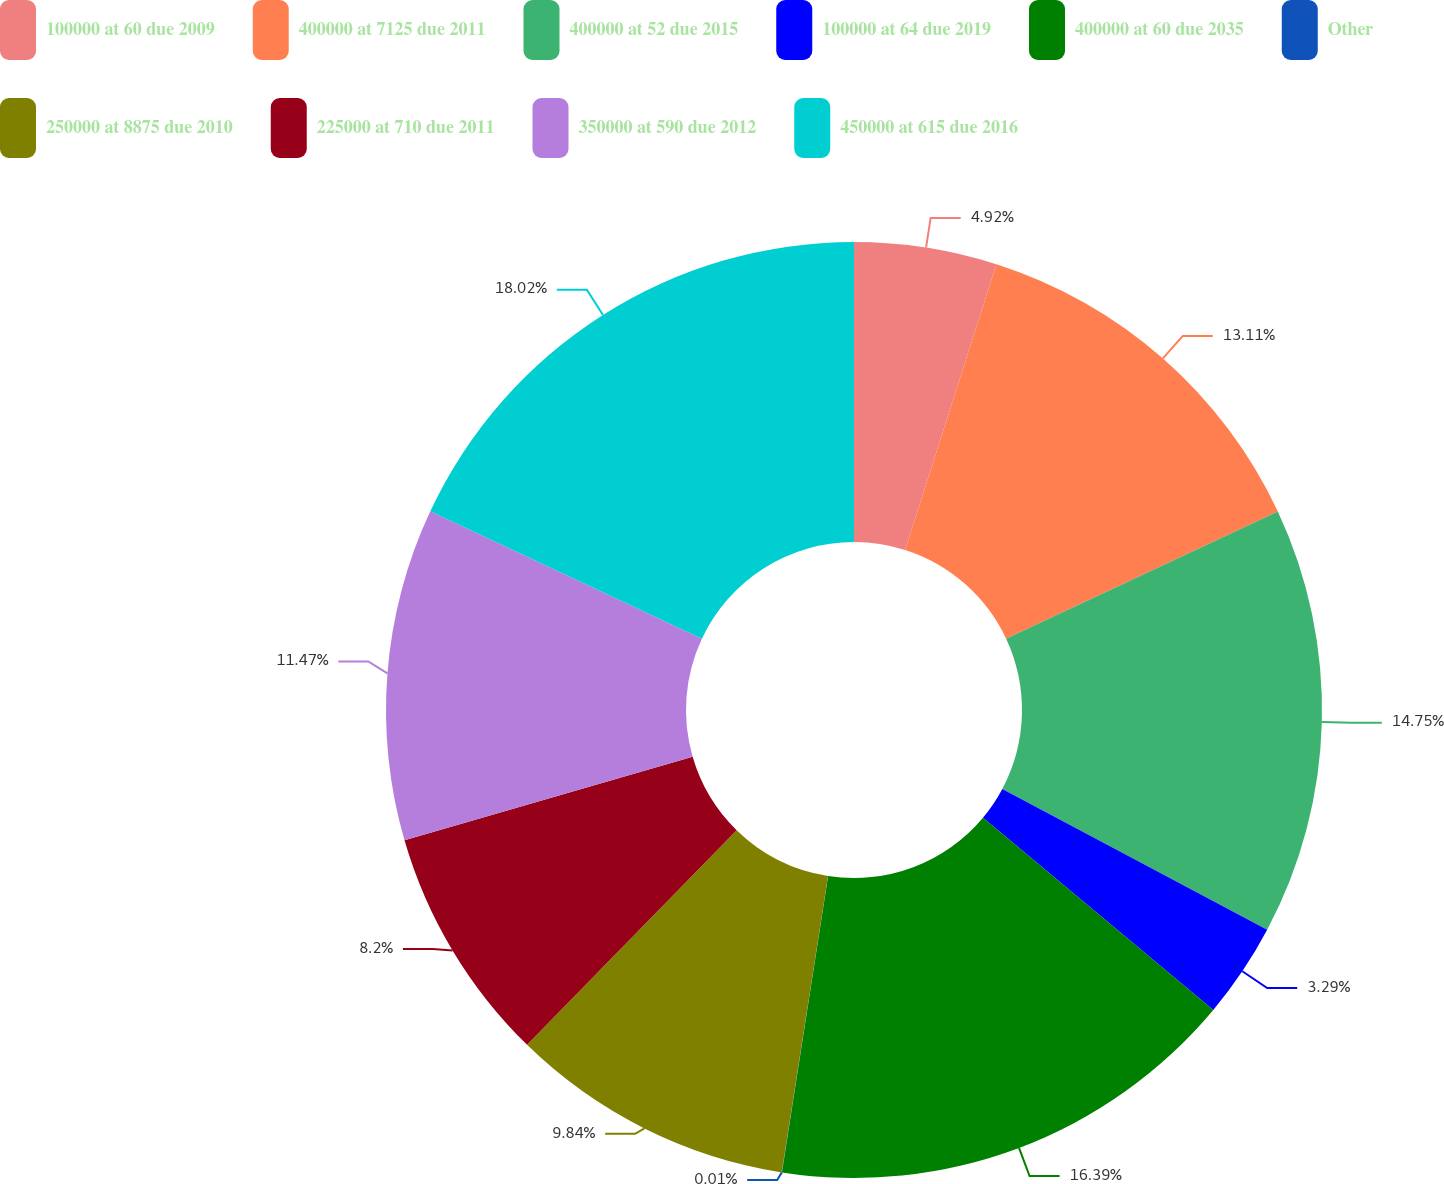<chart> <loc_0><loc_0><loc_500><loc_500><pie_chart><fcel>100000 at 60 due 2009<fcel>400000 at 7125 due 2011<fcel>400000 at 52 due 2015<fcel>100000 at 64 due 2019<fcel>400000 at 60 due 2035<fcel>Other<fcel>250000 at 8875 due 2010<fcel>225000 at 710 due 2011<fcel>350000 at 590 due 2012<fcel>450000 at 615 due 2016<nl><fcel>4.92%<fcel>13.11%<fcel>14.75%<fcel>3.29%<fcel>16.39%<fcel>0.01%<fcel>9.84%<fcel>8.2%<fcel>11.47%<fcel>18.02%<nl></chart> 